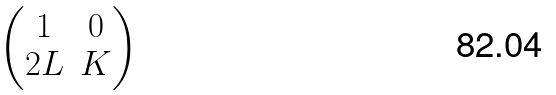<formula> <loc_0><loc_0><loc_500><loc_500>\begin{pmatrix} 1 & 0 \\ 2 L & K \end{pmatrix}</formula> 